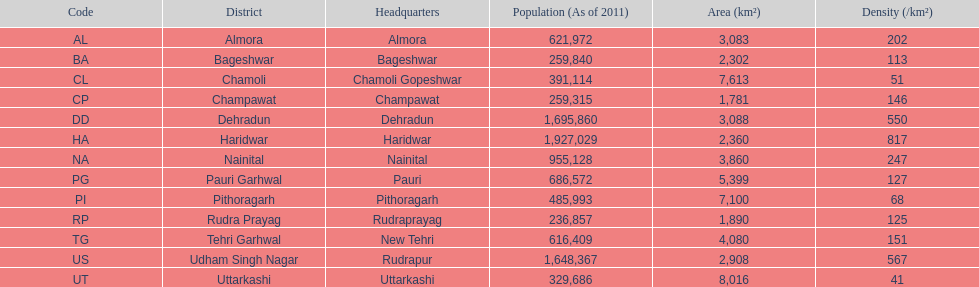Name a district where the density is solely 5 Chamoli. 